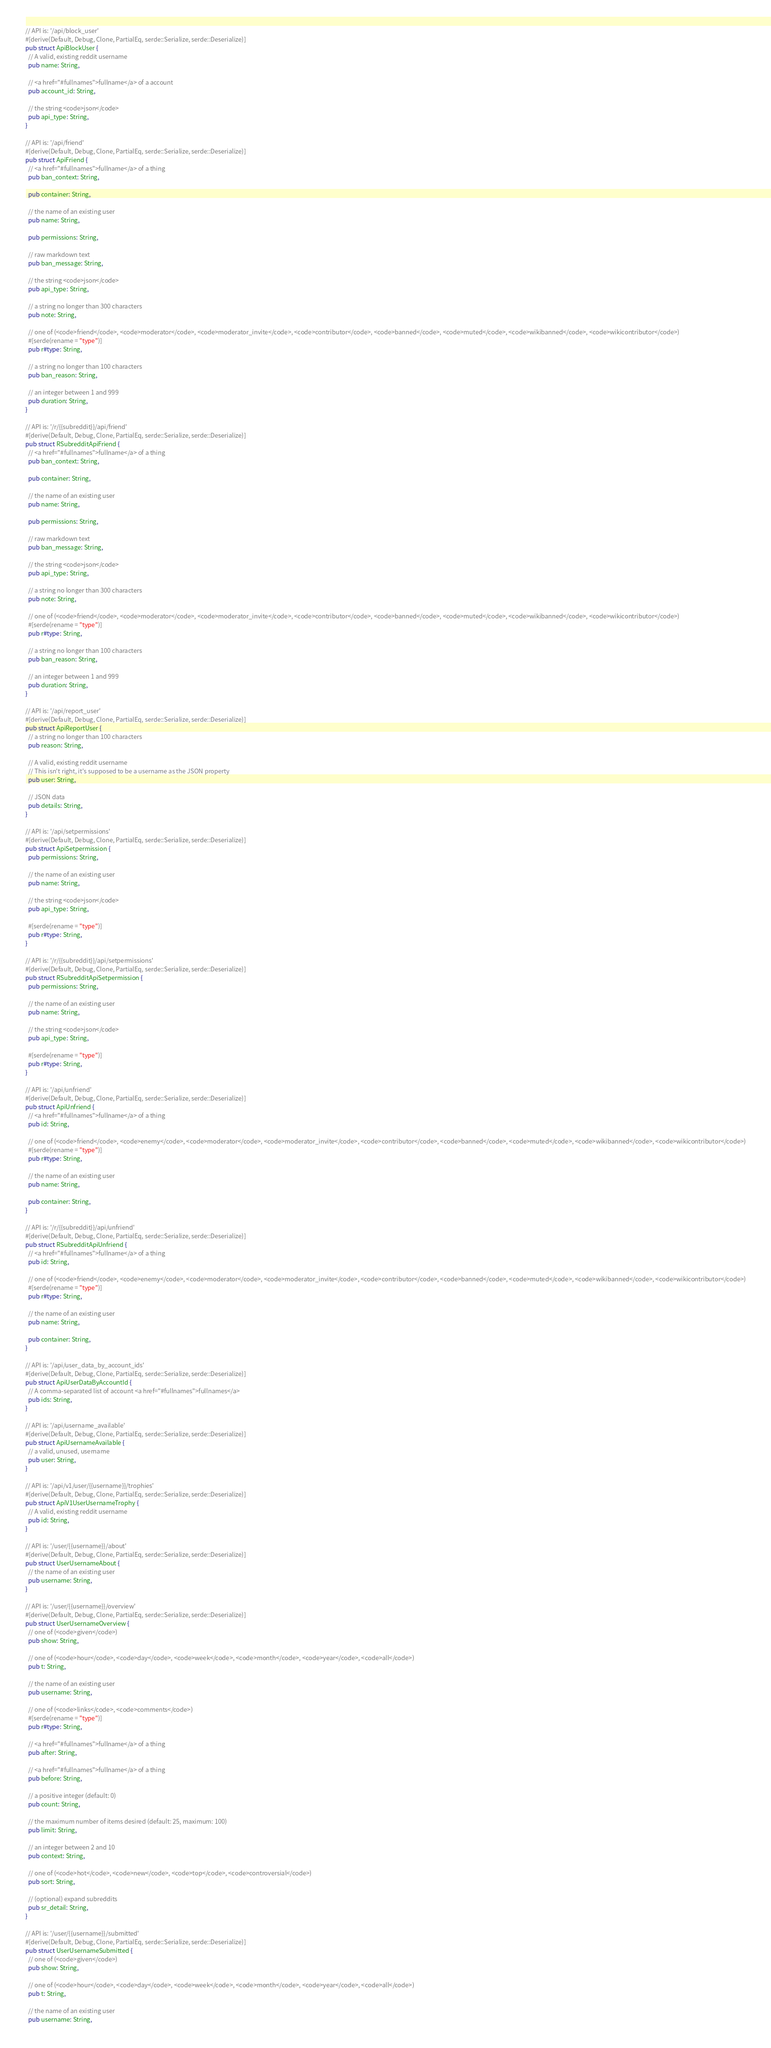Convert code to text. <code><loc_0><loc_0><loc_500><loc_500><_Rust_>// API is: '/api/block_user'
#[derive(Default, Debug, Clone, PartialEq, serde::Serialize, serde::Deserialize)]
pub struct ApiBlockUser {
  // A valid, existing reddit username
  pub name: String,

  // <a href="#fullnames">fullname</a> of a account
  pub account_id: String,

  // the string <code>json</code>
  pub api_type: String,
}

// API is: '/api/friend'
#[derive(Default, Debug, Clone, PartialEq, serde::Serialize, serde::Deserialize)]
pub struct ApiFriend {
  // <a href="#fullnames">fullname</a> of a thing
  pub ban_context: String,

  pub container: String,

  // the name of an existing user
  pub name: String,

  pub permissions: String,

  // raw markdown text
  pub ban_message: String,

  // the string <code>json</code>
  pub api_type: String,

  // a string no longer than 300 characters
  pub note: String,

  // one of (<code>friend</code>, <code>moderator</code>, <code>moderator_invite</code>, <code>contributor</code>, <code>banned</code>, <code>muted</code>, <code>wikibanned</code>, <code>wikicontributor</code>)
  #[serde(rename = "type")]
  pub r#type: String,

  // a string no longer than 100 characters
  pub ban_reason: String,

  // an integer between 1 and 999
  pub duration: String,
}

// API is: '/r/{{subreddit}}/api/friend'
#[derive(Default, Debug, Clone, PartialEq, serde::Serialize, serde::Deserialize)]
pub struct RSubredditApiFriend {
  // <a href="#fullnames">fullname</a> of a thing
  pub ban_context: String,

  pub container: String,

  // the name of an existing user
  pub name: String,

  pub permissions: String,

  // raw markdown text
  pub ban_message: String,

  // the string <code>json</code>
  pub api_type: String,

  // a string no longer than 300 characters
  pub note: String,

  // one of (<code>friend</code>, <code>moderator</code>, <code>moderator_invite</code>, <code>contributor</code>, <code>banned</code>, <code>muted</code>, <code>wikibanned</code>, <code>wikicontributor</code>)
  #[serde(rename = "type")]
  pub r#type: String,

  // a string no longer than 100 characters
  pub ban_reason: String,

  // an integer between 1 and 999
  pub duration: String,
}

// API is: '/api/report_user'
#[derive(Default, Debug, Clone, PartialEq, serde::Serialize, serde::Deserialize)]
pub struct ApiReportUser {
  // a string no longer than 100 characters
  pub reason: String,

  // A valid, existing reddit username
  // This isn't right, it's supposed to be a username as the JSON property
  pub user: String,

  // JSON data
  pub details: String,
}

// API is: '/api/setpermissions'
#[derive(Default, Debug, Clone, PartialEq, serde::Serialize, serde::Deserialize)]
pub struct ApiSetpermission {
  pub permissions: String,

  // the name of an existing user
  pub name: String,

  // the string <code>json</code>
  pub api_type: String,

  #[serde(rename = "type")]
  pub r#type: String,
}

// API is: '/r/{{subreddit}}/api/setpermissions'
#[derive(Default, Debug, Clone, PartialEq, serde::Serialize, serde::Deserialize)]
pub struct RSubredditApiSetpermission {
  pub permissions: String,

  // the name of an existing user
  pub name: String,

  // the string <code>json</code>
  pub api_type: String,

  #[serde(rename = "type")]
  pub r#type: String,
}

// API is: '/api/unfriend'
#[derive(Default, Debug, Clone, PartialEq, serde::Serialize, serde::Deserialize)]
pub struct ApiUnfriend {
  // <a href="#fullnames">fullname</a> of a thing
  pub id: String,

  // one of (<code>friend</code>, <code>enemy</code>, <code>moderator</code>, <code>moderator_invite</code>, <code>contributor</code>, <code>banned</code>, <code>muted</code>, <code>wikibanned</code>, <code>wikicontributor</code>)
  #[serde(rename = "type")]
  pub r#type: String,

  // the name of an existing user
  pub name: String,

  pub container: String,
}

// API is: '/r/{{subreddit}}/api/unfriend'
#[derive(Default, Debug, Clone, PartialEq, serde::Serialize, serde::Deserialize)]
pub struct RSubredditApiUnfriend {
  // <a href="#fullnames">fullname</a> of a thing
  pub id: String,

  // one of (<code>friend</code>, <code>enemy</code>, <code>moderator</code>, <code>moderator_invite</code>, <code>contributor</code>, <code>banned</code>, <code>muted</code>, <code>wikibanned</code>, <code>wikicontributor</code>)
  #[serde(rename = "type")]
  pub r#type: String,

  // the name of an existing user
  pub name: String,

  pub container: String,
}

// API is: '/api/user_data_by_account_ids'
#[derive(Default, Debug, Clone, PartialEq, serde::Serialize, serde::Deserialize)]
pub struct ApiUserDataByAccountId {
  // A comma-separated list of account <a href="#fullnames">fullnames</a>
  pub ids: String,
}

// API is: '/api/username_available'
#[derive(Default, Debug, Clone, PartialEq, serde::Serialize, serde::Deserialize)]
pub struct ApiUsernameAvailable {
  // a valid, unused, username
  pub user: String,
}

// API is: '/api/v1/user/{{username}}/trophies'
#[derive(Default, Debug, Clone, PartialEq, serde::Serialize, serde::Deserialize)]
pub struct ApiV1UserUsernameTrophy {
  // A valid, existing reddit username
  pub id: String,
}

// API is: '/user/{{username}}/about'
#[derive(Default, Debug, Clone, PartialEq, serde::Serialize, serde::Deserialize)]
pub struct UserUsernameAbout {
  // the name of an existing user
  pub username: String,
}

// API is: '/user/{{username}}/overview'
#[derive(Default, Debug, Clone, PartialEq, serde::Serialize, serde::Deserialize)]
pub struct UserUsernameOverview {
  // one of (<code>given</code>)
  pub show: String,

  // one of (<code>hour</code>, <code>day</code>, <code>week</code>, <code>month</code>, <code>year</code>, <code>all</code>)
  pub t: String,

  // the name of an existing user
  pub username: String,

  // one of (<code>links</code>, <code>comments</code>)
  #[serde(rename = "type")]
  pub r#type: String,

  // <a href="#fullnames">fullname</a> of a thing
  pub after: String,

  // <a href="#fullnames">fullname</a> of a thing
  pub before: String,

  // a positive integer (default: 0)
  pub count: String,

  // the maximum number of items desired (default: 25, maximum: 100)
  pub limit: String,

  // an integer between 2 and 10
  pub context: String,

  // one of (<code>hot</code>, <code>new</code>, <code>top</code>, <code>controversial</code>)
  pub sort: String,

  // (optional) expand subreddits
  pub sr_detail: String,
}

// API is: '/user/{{username}}/submitted'
#[derive(Default, Debug, Clone, PartialEq, serde::Serialize, serde::Deserialize)]
pub struct UserUsernameSubmitted {
  // one of (<code>given</code>)
  pub show: String,

  // one of (<code>hour</code>, <code>day</code>, <code>week</code>, <code>month</code>, <code>year</code>, <code>all</code>)
  pub t: String,

  // the name of an existing user
  pub username: String,
</code> 